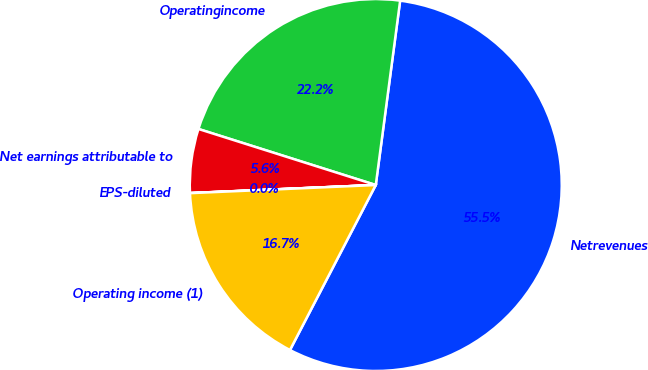Convert chart to OTSL. <chart><loc_0><loc_0><loc_500><loc_500><pie_chart><fcel>Netrevenues<fcel>Operatingincome<fcel>Net earnings attributable to<fcel>EPS-diluted<fcel>Operating income (1)<nl><fcel>55.54%<fcel>22.22%<fcel>5.56%<fcel>0.01%<fcel>16.67%<nl></chart> 